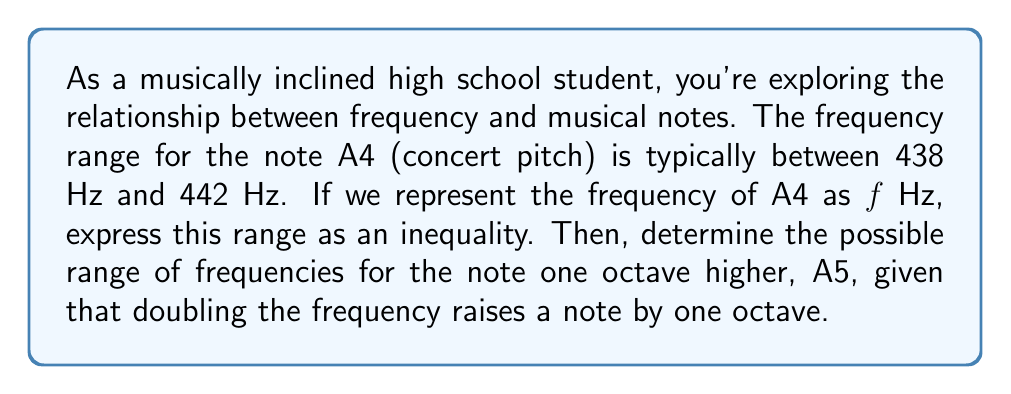Could you help me with this problem? Let's approach this step-by-step:

1) For A4, we're told the frequency range is between 438 Hz and 442 Hz. We can express this as an inequality:

   $438 \leq f \leq 442$

   where $f$ represents the frequency of A4 in Hz.

2) To find the range for A5, we need to consider that A5 is one octave higher than A4. In music theory, doubling the frequency of a note raises it by one octave.

3) Therefore, to get the frequency range for A5, we need to double both ends of our inequality for A4:

   $2(438) \leq 2f \leq 2(442)$

4) Simplifying:

   $876 \leq 2f \leq 884$

5) To express this in terms of the frequency of A5, let's call it $f_5$. Since $f_5 = 2f$, we can substitute directly:

   $876 \leq f_5 \leq 884$

This inequality represents the possible range of frequencies for A5 in Hz.
Answer: The range of frequencies for A4: $438 \leq f \leq 442$ Hz
The range of frequencies for A5: $876 \leq f_5 \leq 884$ Hz 